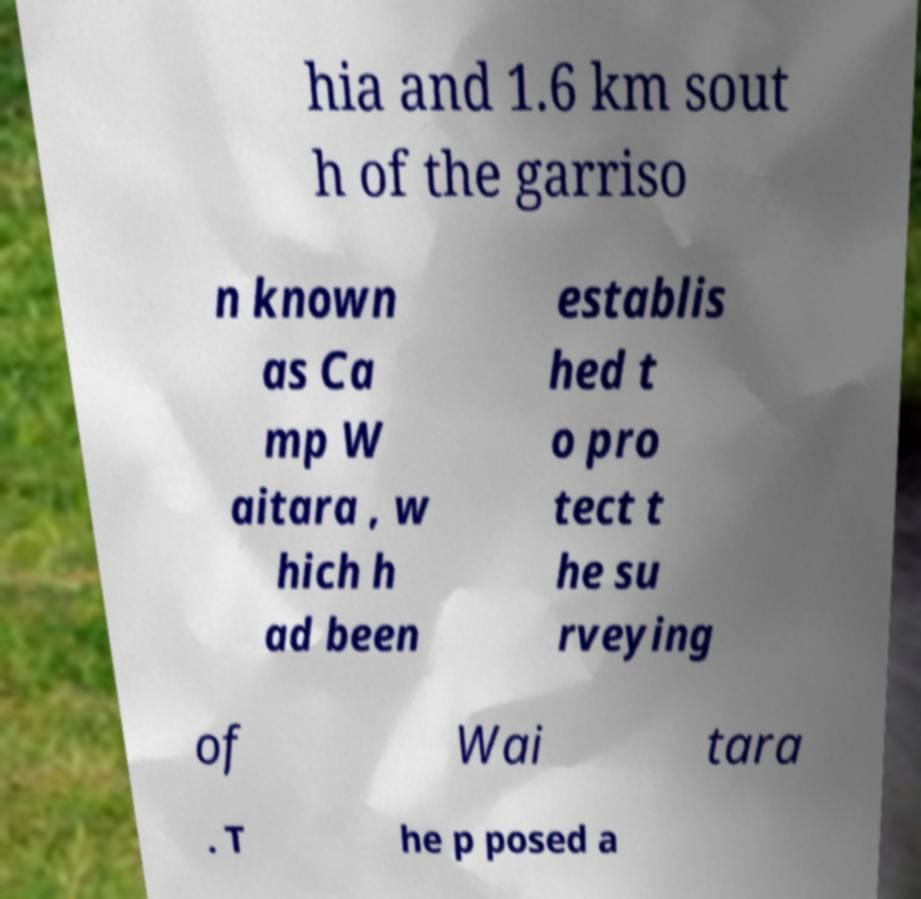Could you assist in decoding the text presented in this image and type it out clearly? hia and 1.6 km sout h of the garriso n known as Ca mp W aitara , w hich h ad been establis hed t o pro tect t he su rveying of Wai tara . T he p posed a 